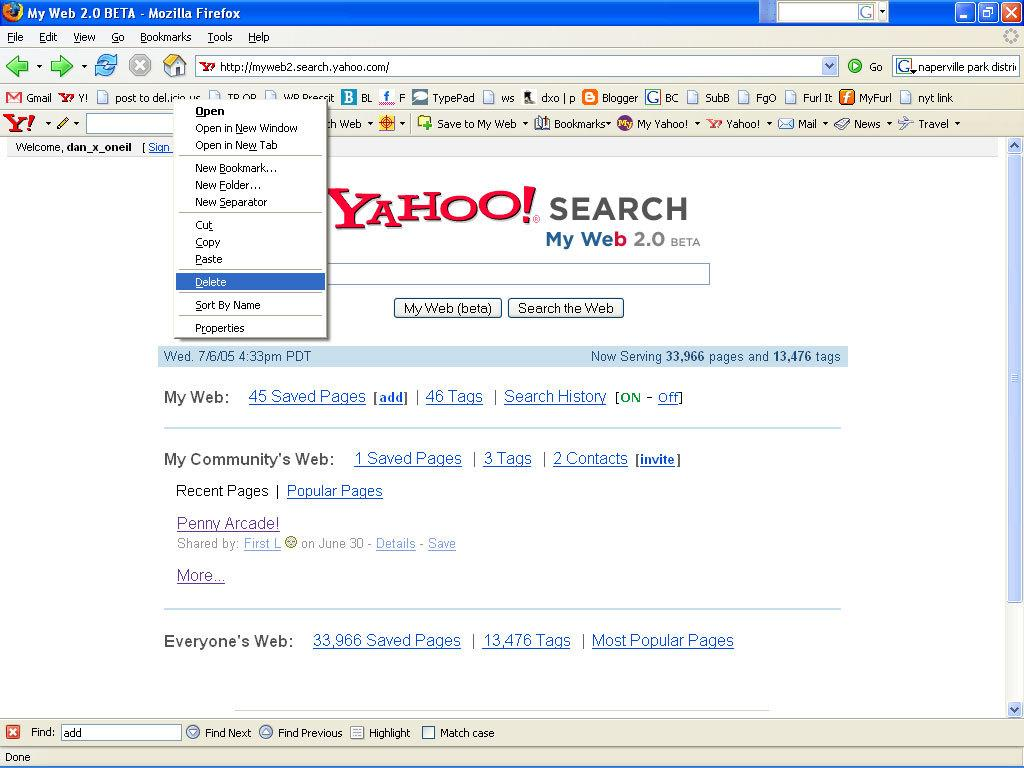Provide a one-sentence caption for the provided image. A screenshot of a Firefox browser running in Windows XP where the landing page is Yahoo Search. 